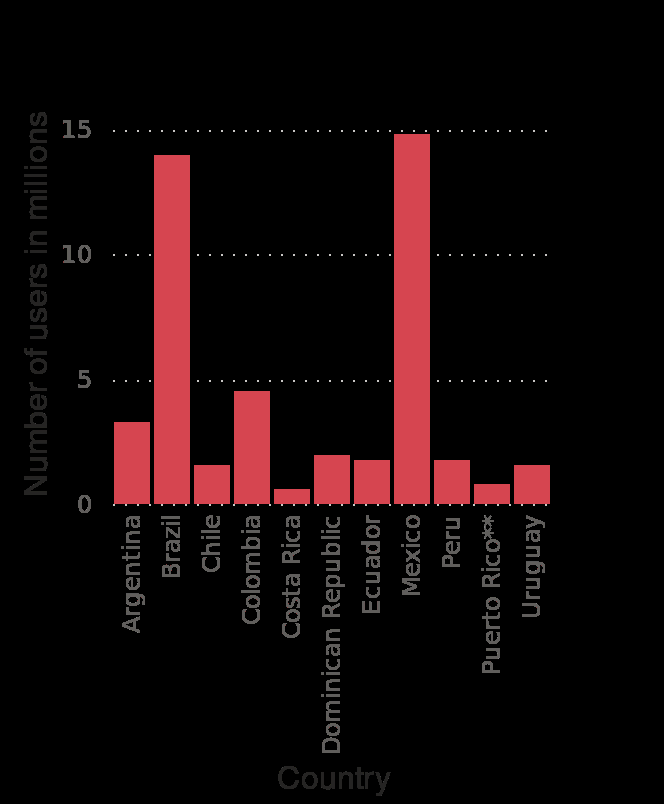<image>
How many countries are mentioned in the figure as top Snapchat users?  Two countries, Brazil and Mexico. Which are the top two countries that use Snapchat?  Brazil and Mexico. What does the x-axis represent in the bar chart?  The x-axis represents the selected Latin American countries. 